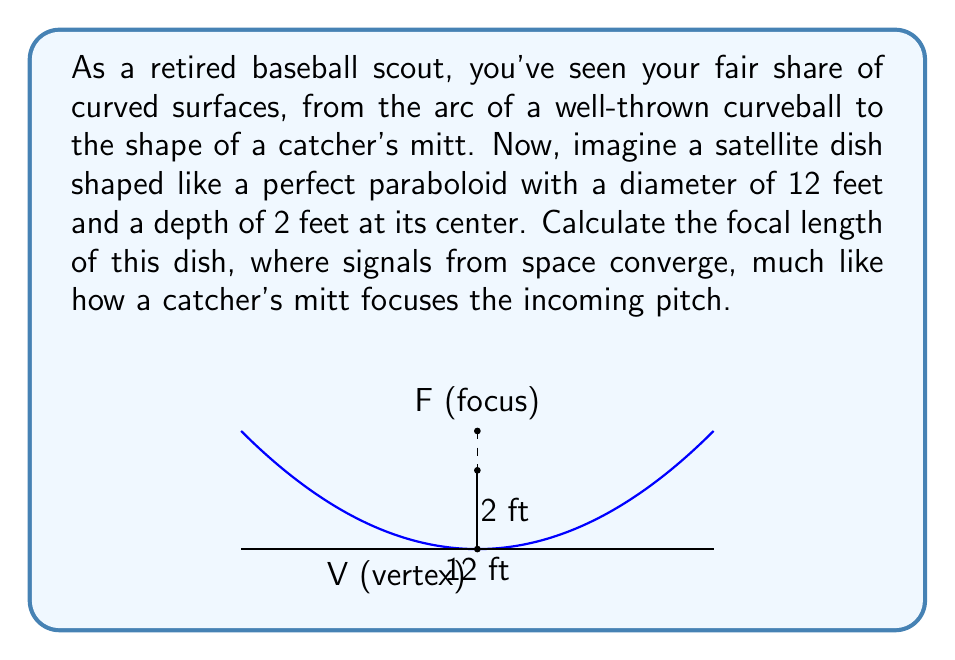Give your solution to this math problem. Let's approach this step-by-step:

1) The equation of a parabola with vertex at the origin and axis of symmetry along the y-axis is:

   $$y = \frac{1}{4p}x^2$$

   where $p$ is the focal length.

2) We know that the parabola passes through the point (6, 2), as the radius is 6 feet and the depth is 2 feet. Let's substitute these values:

   $$2 = \frac{1}{4p}(6^2)$$

3) Simplify:
   
   $$2 = \frac{36}{4p}$$
   $$2 = \frac{9}{p}$$

4) Solve for $p$:
   
   $$p = \frac{9}{2} = 4.5$$

5) Therefore, the focal length is 4.5 feet.

This means that the signals will converge at a point 4.5 feet from the vertex of the parabola, similar to how a pitched ball converges at the sweet spot of a catcher's mitt.
Answer: $4.5$ feet 